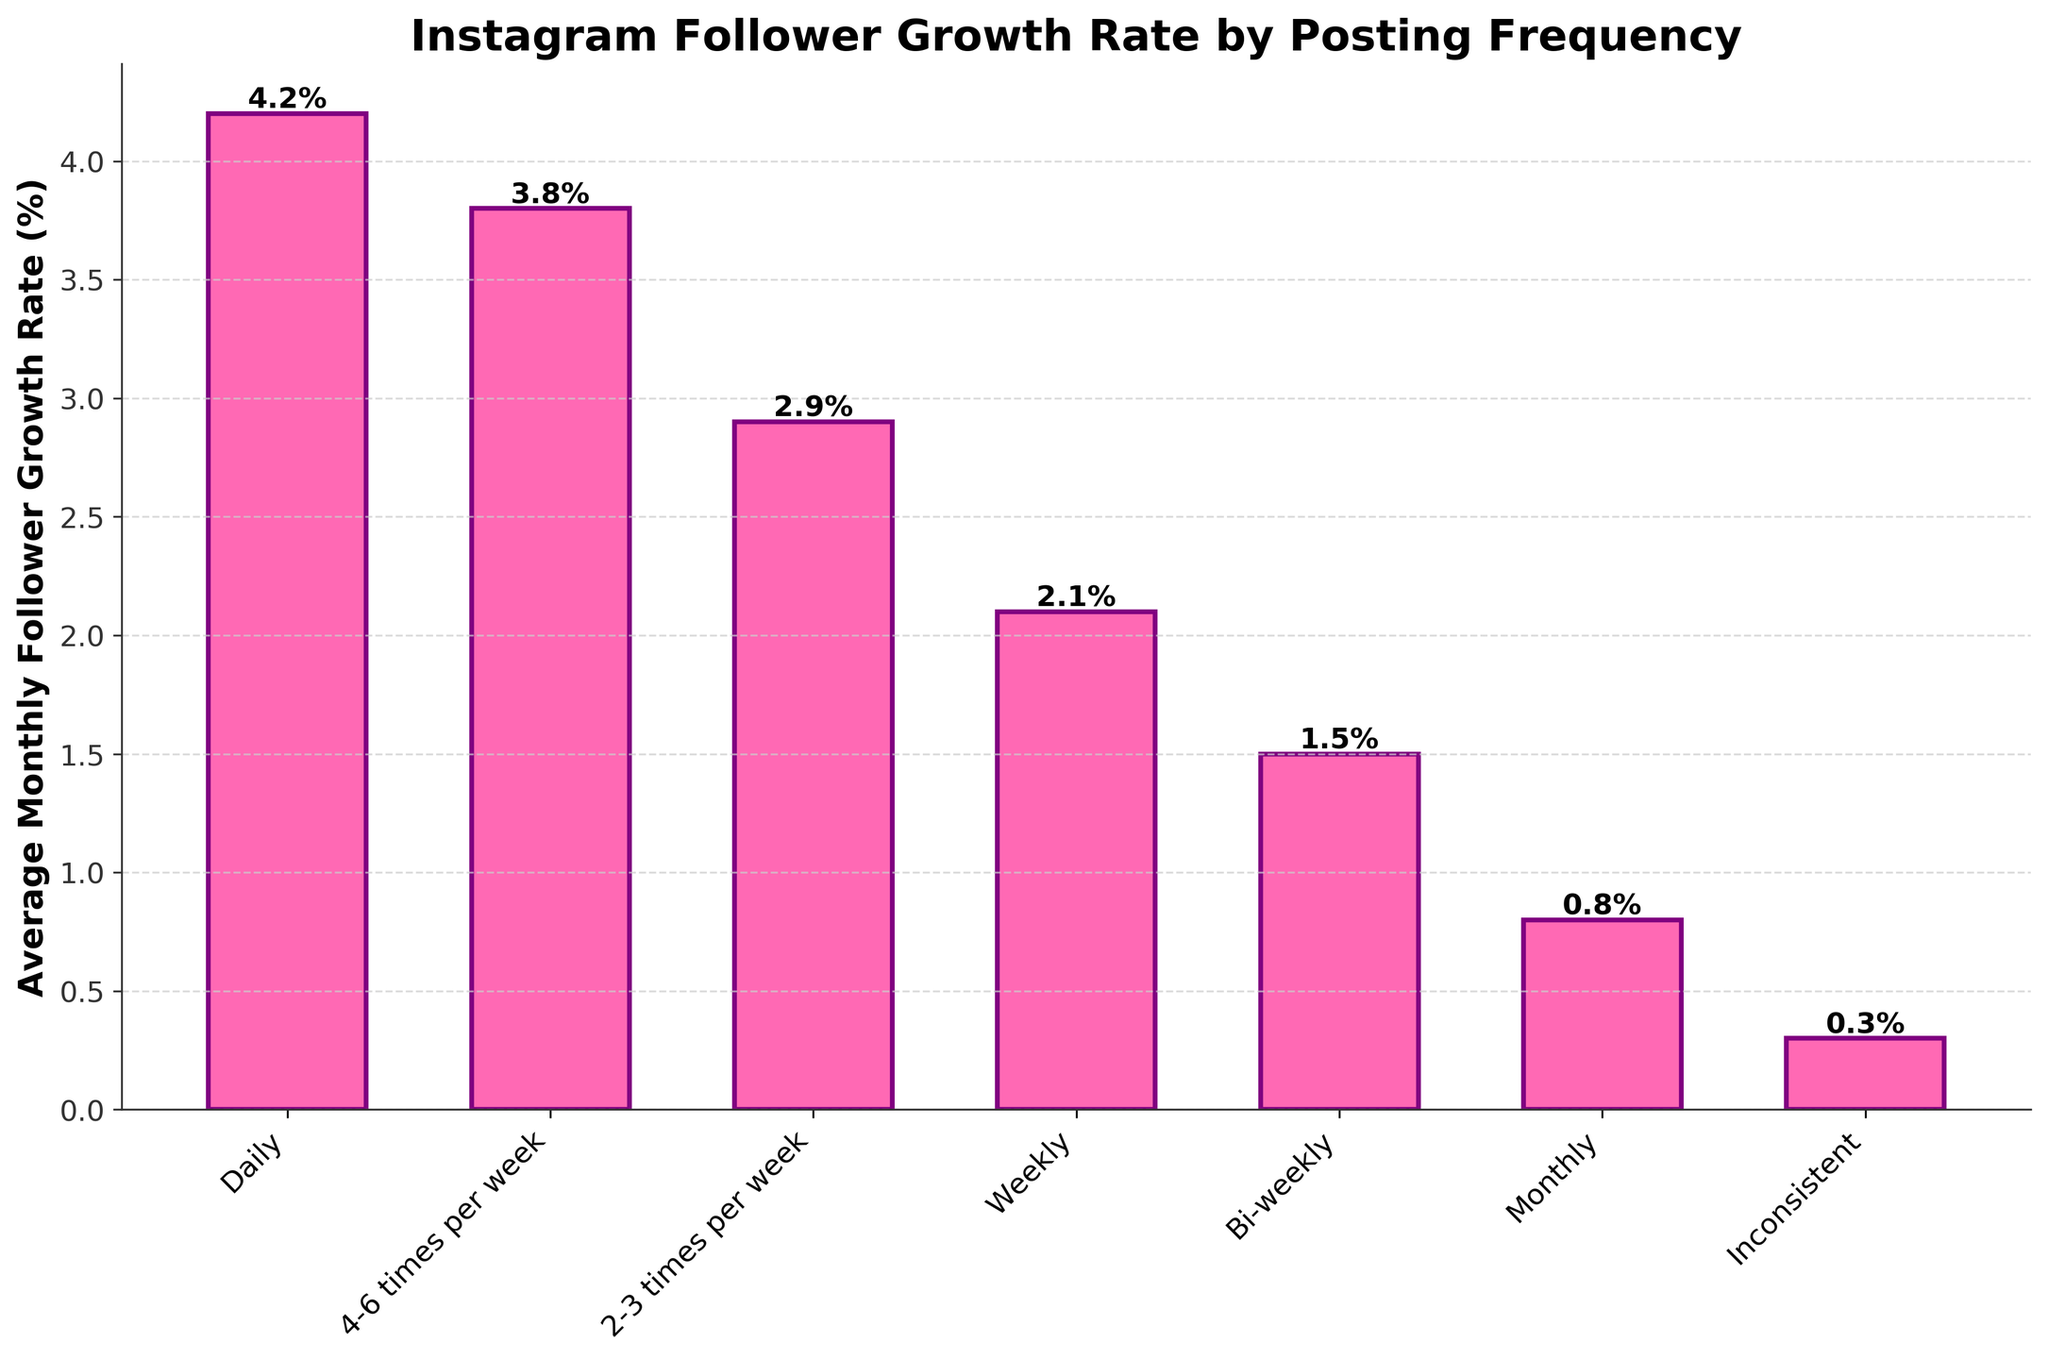What's the average monthly follower growth rate for artists who post daily? Look at the bar corresponding to "Daily" in the figure. The height of this bar represents the average monthly follower growth rate for artists who post daily.
Answer: 4.2% Which posting frequency category results in the lowest average monthly follower growth rate? To find the posting frequency category with the lowest average monthly follower growth rate, identify the shortest bar in the chart. The shortest bar represents "Inconsistent".
Answer: Inconsistent How much higher is the average monthly follower growth rate for posting weekly compared to posting bi-weekly? First, identify the bars for "Weekly" and "Bi-weekly". The heights of these bars are 2.1% and 1.5% respectively. Calculate the difference: 2.1% - 1.5% = 0.6%
Answer: 0.6% What's the total average monthly follower growth rate for artists who post daily and those who post 4-6 times per week? Look at the bars for "Daily" and "4-6 times per week". The heights are 4.2% and 3.8% respectively. Sum these values to get the total: 4.2% + 3.8% = 8.0%
Answer: 8.0% Compare the average monthly follower growth rates between artists who post bi-weekly and those who post inconsistently. Which is higher and by how much? Identify the bars for "Bi-weekly" and "Inconsistent". The heights are 1.5% and 0.3%, respectively. Calculate the difference: 1.5% - 0.3% = 1.2%. "Bi-weekly" has a higher rate.
Answer: Bi-weekly, by 1.2% What is the difference in average monthly follower growth rates between artists who post daily and those who post monthly? Look at the bars for "Daily" and "Monthly". The heights are 4.2% and 0.8% respectively. Calculate the difference: 4.2% - 0.8% = 3.4%
Answer: 3.4% Arrange the posting frequencies in descending order based on their average monthly follower growth rates. Read the heights of all the bars and arrange their labels accordingly: Daily (4.2%), 4-6 times per week (3.8%), 2-3 times per week (2.9%), Weekly (2.1%), Bi-weekly (1.5%), Monthly (0.8%), Inconsistent (0.3%).
Answer: Daily, 4-6 times per week, 2-3 times per week, Weekly, Bi-weekly, Monthly, Inconsistent If an artist wants to have an average monthly follower growth rate of at least 3%, what is the minimum posting frequency they should maintain? Look at the bars and identify the ones with heights greater than or equal to 3%. These bars are for "Daily" and "4-6 times per week", and "2-3 times per week". The minimum posting frequency among them is "2-3 times per week".
Answer: 2-3 times per week What's the visual difference between the bars representing "Bi-weekly" and "Monthly"? Observe the bars for "Bi-weekly" and "Monthly". The "Bi-weekly" bar is taller, and both bars are colored pink with purple edges. The main difference in height is 1.5% for "Bi-weekly" and 0.8% for "Monthly".
Answer: "Bi-weekly" bar is taller How does the average monthly follower growth rate change as the posting frequency decreases from "Daily" to "Inconsistent"? Trace the bars from "Daily" to "Inconsistent". You'll notice the heights gradually decrease: Daily (4.2%), 4-6 times per week (3.8%), 2-3 times per week (2.9%), Weekly (2.1%), Bi-weekly (1.5%), Monthly (0.8%), Inconsistent (0.3%).
Answer: It decreases 